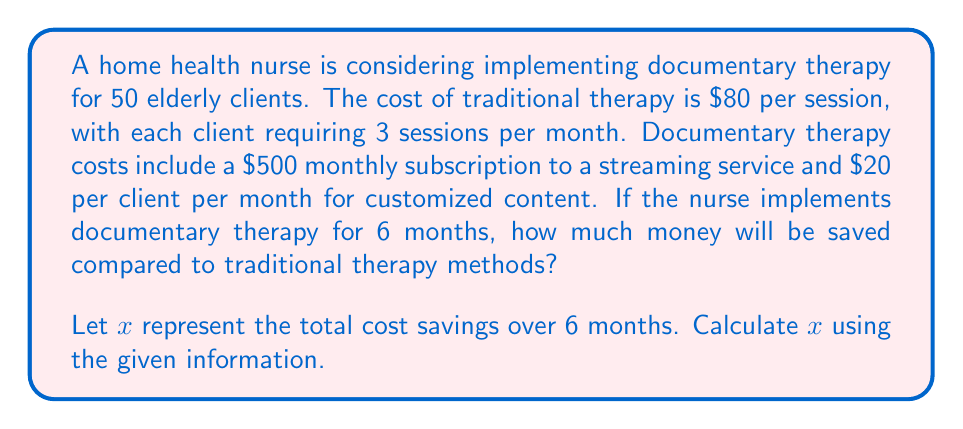Could you help me with this problem? To solve this problem, we need to calculate the costs for both traditional therapy and documentary therapy over 6 months, then find the difference.

1. Calculate the cost of traditional therapy:
   - Cost per client per month: $80 \times 3 = $240
   - Cost for 50 clients per month: $240 \times 50 = $12,000
   - Cost for 6 months: $12,000 \times 6 = $72,000

2. Calculate the cost of documentary therapy:
   - Monthly subscription: $500
   - Monthly cost per client: $20 \times 50 = $1,000
   - Total monthly cost: $500 + $1,000 = $1,500
   - Cost for 6 months: $1,500 \times 6 = $9,000

3. Calculate the cost savings:
   $$x = \text{Traditional Therapy Cost} - \text{Documentary Therapy Cost}$$
   $$x = $72,000 - $9,000 = $63,000$$

Therefore, the cost savings over 6 months by implementing documentary therapy is $63,000.
Answer: $x = $63,000 